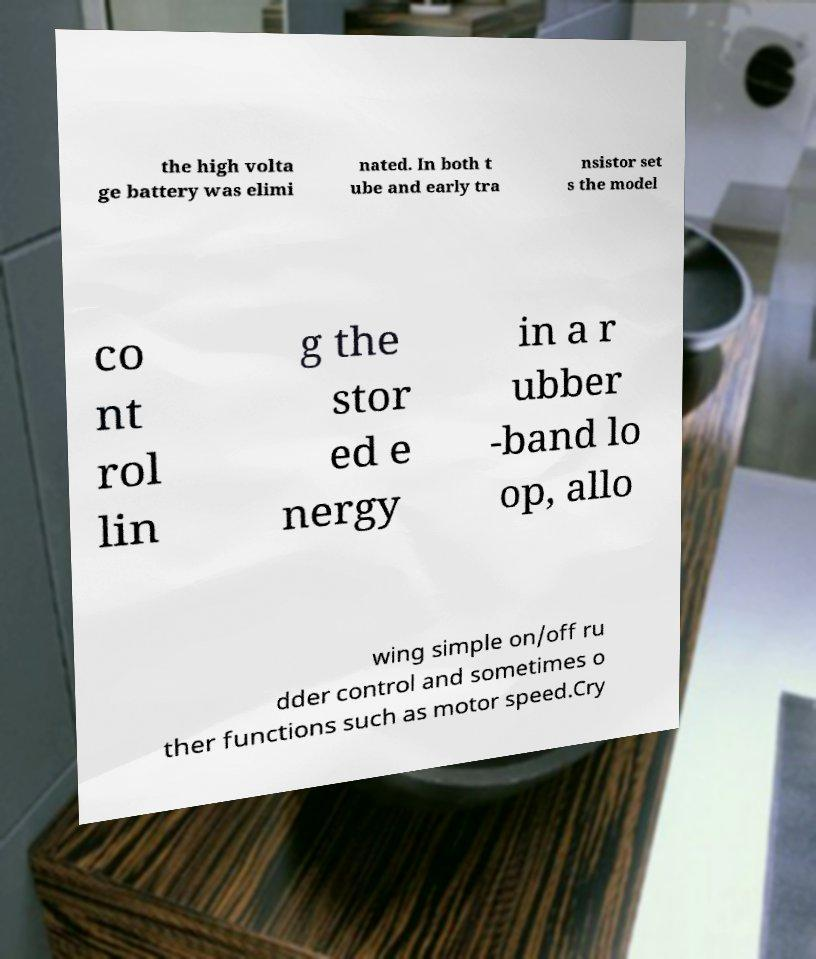There's text embedded in this image that I need extracted. Can you transcribe it verbatim? the high volta ge battery was elimi nated. In both t ube and early tra nsistor set s the model co nt rol lin g the stor ed e nergy in a r ubber -band lo op, allo wing simple on/off ru dder control and sometimes o ther functions such as motor speed.Cry 